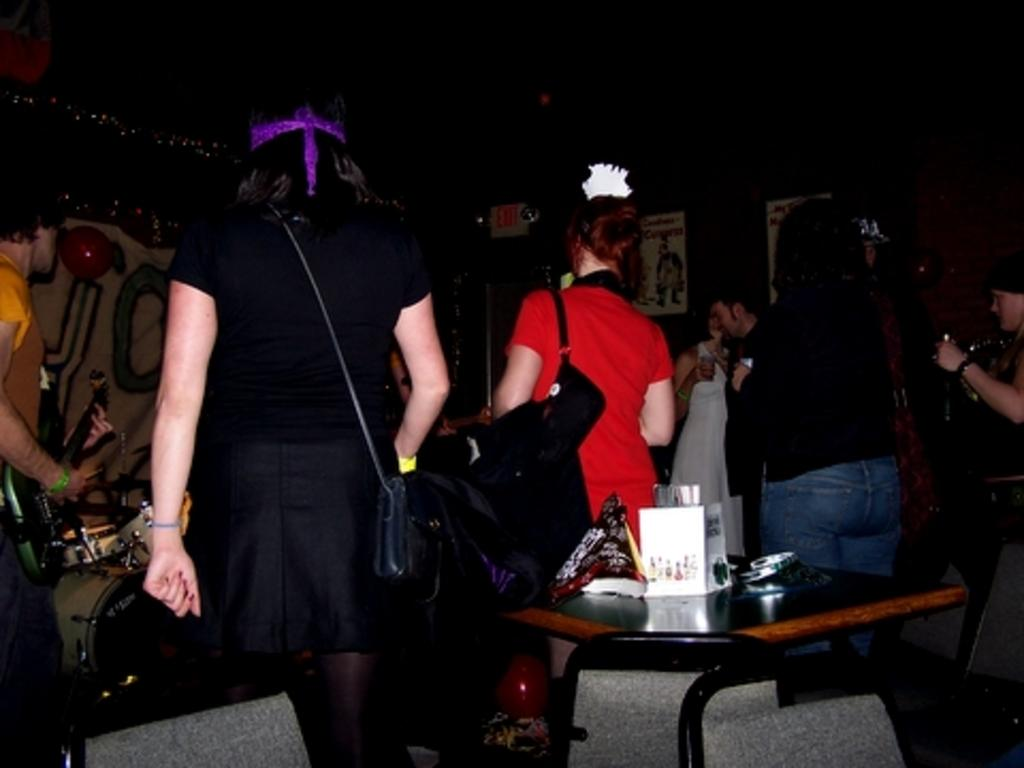What are the people near the drums doing in the image? There is a group of people standing near the drums on the left side of the image. Where are the other people in the image located? There is another group of people standing at a table in the image. What can be seen in the image besides the people and the drums? There are objects visible in the image. Is there any furniture present in the image? Yes, there is a chair in the image. What type of bun is being used as a cushion for the chair in the image? There is no bun present in the image, and the chair does not have a cushion. Can you describe the comfort level of the chair in the image? The comfort level of the chair cannot be determined from the image alone. 